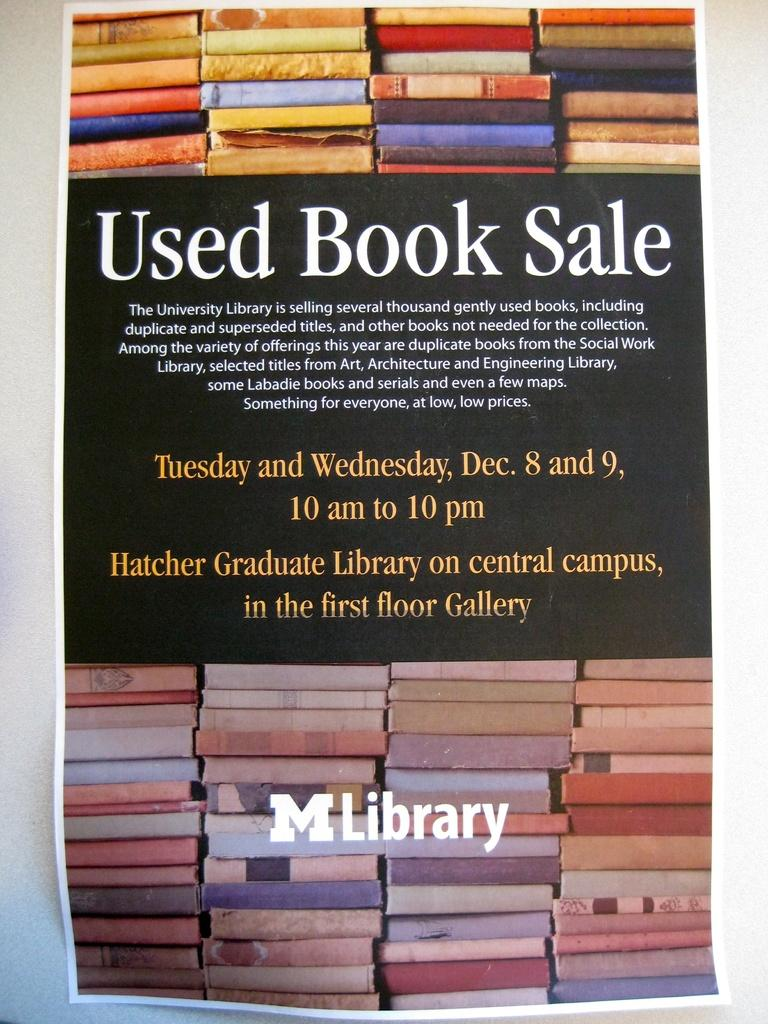<image>
Write a terse but informative summary of the picture. You should attend the Used Book Sale on Tuesday and Wednesday, Dec 8 and 9. 